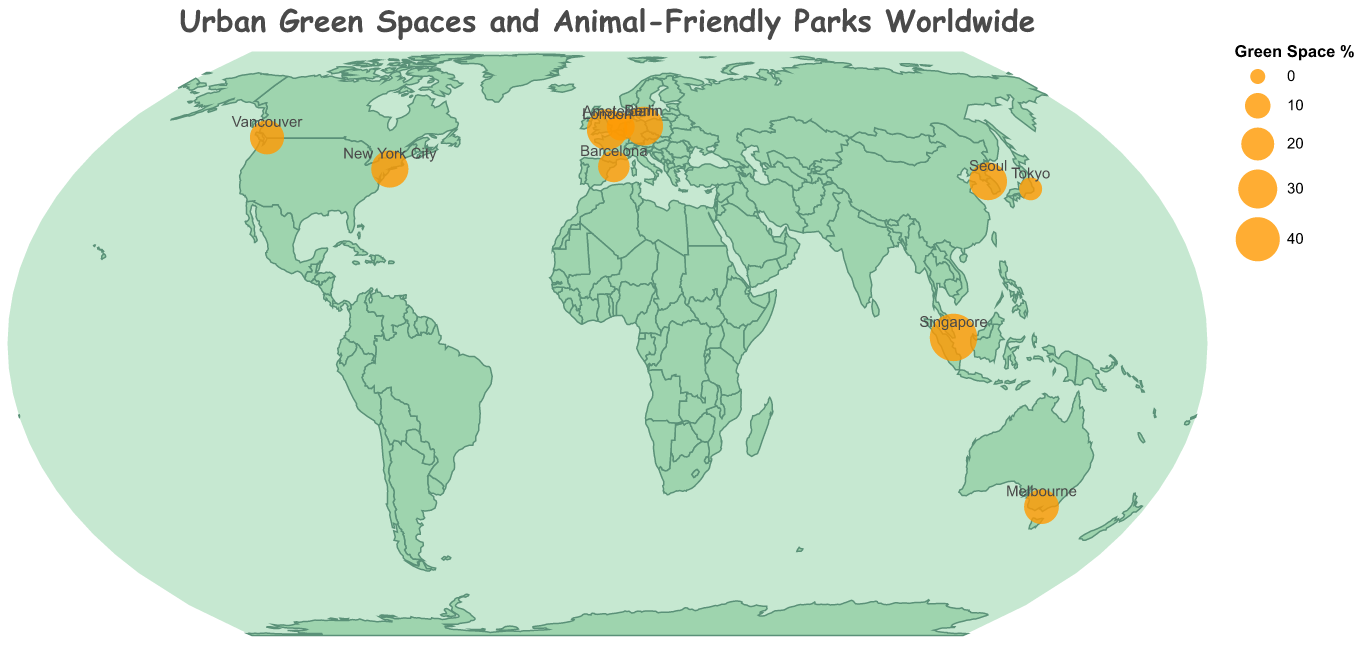what is the green space percentage of Berlin? Look for the city Berlin on the map, check the tooltip for Green Space Percentage.
Answer: 30 Which city has the highest number of small animal-friendly parks? Find the highest value for Animal-Friendly Parks by looking at the tooltip for each city.
Answer: Singapore What is the difference in green space percentage between London and Tokyo? Subtract Tokyo's Green Space Percentage from London's: 33 - 7.
Answer: 26 Which city has the smallest circle on the map, indicating the lowest green space percentage? The smallest circle indicates the lowest green space percentage. Tokyo's circle is the smallest.
Answer: Tokyo What is the title of the figure? Look at the title displayed at the top of the figure.
Answer: Urban Green Spaces and Animal-Friendly Parks Worldwide Which city in Europe has the most small animal-friendly parks? Look for European cities and compare the Animal-Friendly Parks values.
Answer: London How many cities have over 40 small animal-friendly parks? Check each city’s value for Animal-Friendly Parks and count those above 40 (New York City, London, Singapore, Berlin, Seoul).
Answer: 5 Compare the green space percentage between Vancouver and Melbourne. Check the Green Space Percentage for both cities and compare: Vancouver (22) vs Melbourne (23).
Answer: Melbourne has a higher percentage What is the average green space percentage of all the cities? Sum up the Green Space Percentages for all cities and divide by the number of cities (10): (27+33+7+47+30+23+22+13+28+18)/10 = 24.8.
Answer: 24.8 How many animal-friendly parks are there in Tokyo compared to Amsterdam? Compare the small animal-friendly parks values for Tokyo (18) and Amsterdam (28).
Answer: Amsterdam has 10 more parks 